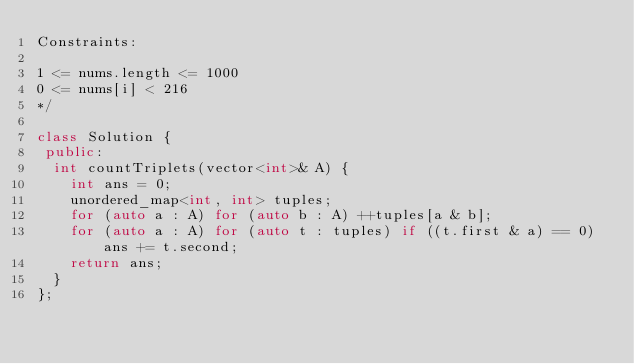Convert code to text. <code><loc_0><loc_0><loc_500><loc_500><_C++_>Constraints:

1 <= nums.length <= 1000
0 <= nums[i] < 216
*/

class Solution {
 public:
  int countTriplets(vector<int>& A) {
    int ans = 0;
    unordered_map<int, int> tuples;
    for (auto a : A) for (auto b : A) ++tuples[a & b];
    for (auto a : A) for (auto t : tuples) if ((t.first & a) == 0) ans += t.second;
    return ans;
  }
};</code> 